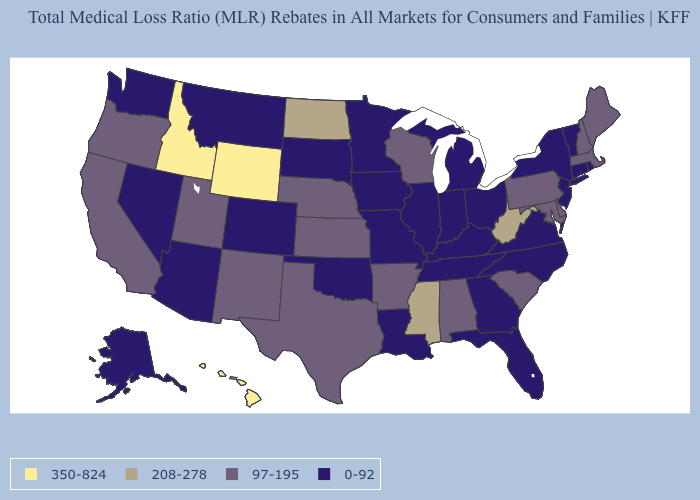Name the states that have a value in the range 350-824?
Write a very short answer. Hawaii, Idaho, Wyoming. Among the states that border New Hampshire , which have the lowest value?
Short answer required. Vermont. What is the value of Pennsylvania?
Give a very brief answer. 97-195. What is the value of Arkansas?
Quick response, please. 97-195. What is the value of Delaware?
Write a very short answer. 97-195. Name the states that have a value in the range 350-824?
Keep it brief. Hawaii, Idaho, Wyoming. Does Illinois have the lowest value in the USA?
Write a very short answer. Yes. Which states have the highest value in the USA?
Short answer required. Hawaii, Idaho, Wyoming. Among the states that border Arizona , which have the lowest value?
Write a very short answer. Colorado, Nevada. What is the highest value in the USA?
Quick response, please. 350-824. Which states have the lowest value in the Northeast?
Write a very short answer. Connecticut, New Jersey, New York, Rhode Island, Vermont. Among the states that border Kansas , does Colorado have the highest value?
Concise answer only. No. Does Louisiana have a higher value than Oklahoma?
Concise answer only. No. Does Rhode Island have a lower value than Pennsylvania?
Concise answer only. Yes. Which states hav the highest value in the West?
Be succinct. Hawaii, Idaho, Wyoming. 